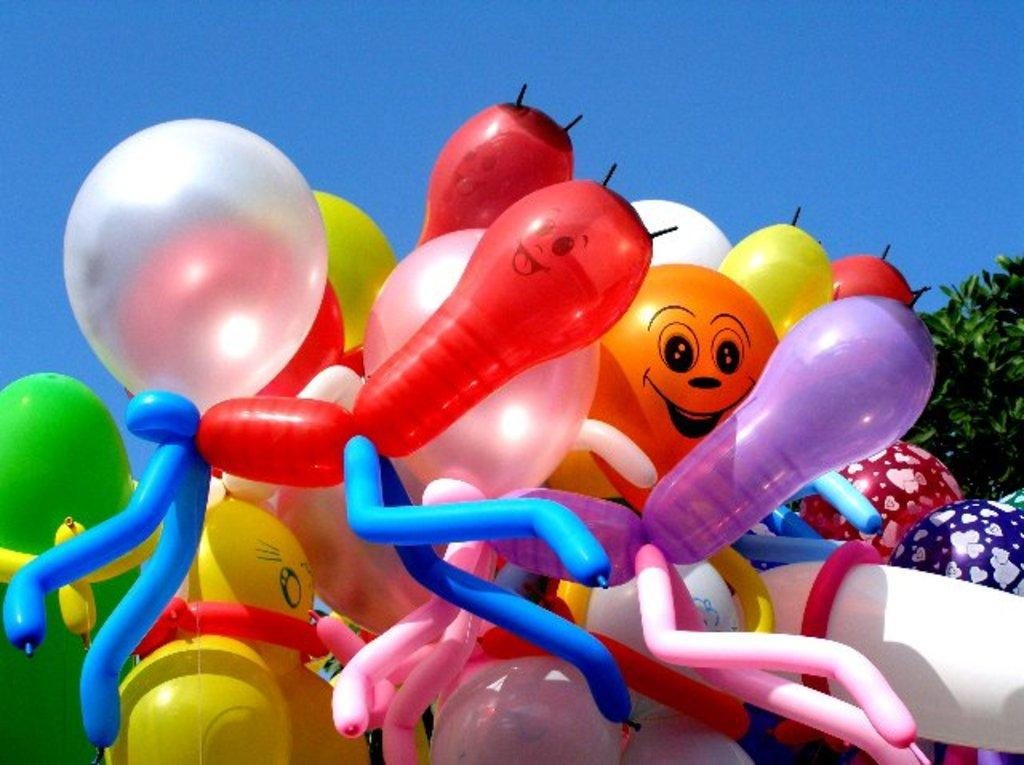What objects are floating in the image? There are balloons in the image. What type of vegetation is present in the image? There are trees in the image. What part of the natural environment is visible in the image? The sky is visible in the image. What type of sound can be heard coming from the birthday celebration in the image? There is no mention of a birthday celebration or any sounds in the image, so it's not possible to determine what, if any, sounds might be heard. 